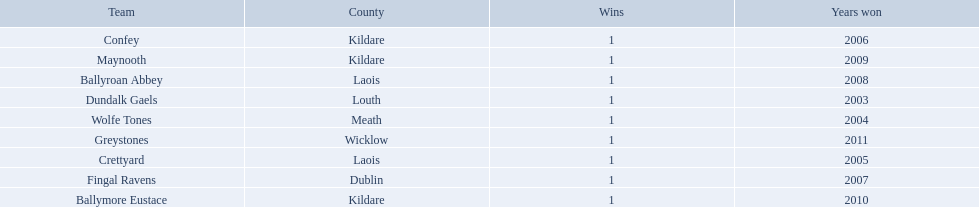What county is ballymore eustace from? Kildare. Besides convey, which other team is from the same county? Maynooth. 